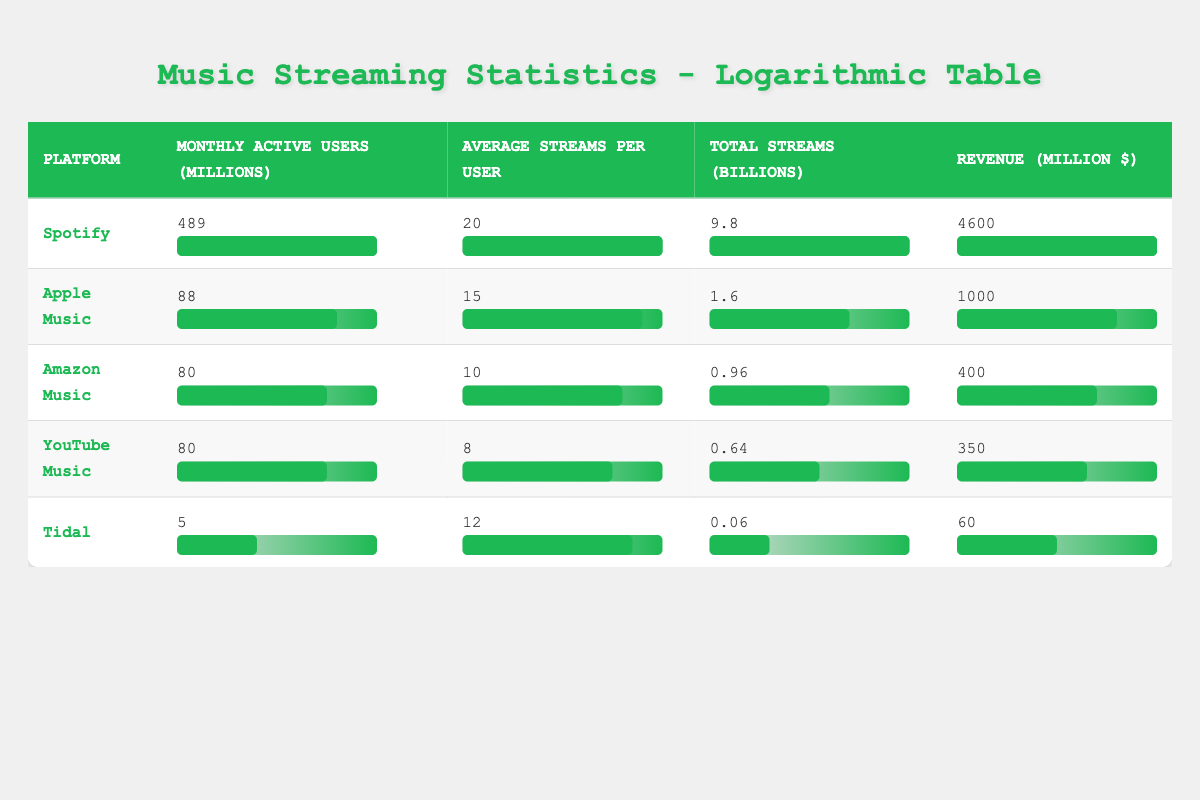What is the total revenue of Spotify? According to the table, the revenue for Spotify is listed directly under the revenue column, which shows 4600 million dollars.
Answer: 4600 million dollars Which platform has the highest number of monthly active users? The table lists monthly active users for each platform. Spotify has 489 million users, the highest compared to the other platforms.
Answer: Spotify What is the average number of streams per user on Apple Music? The table shows the average streams per user for Apple Music as 15. This value is found in the respective column for Apple Music.
Answer: 15 How many total streams did Tidal have in billions? Looking at the total streams column, Tidal is listed with 0.06 billion streams, which is directly taken from the table.
Answer: 0.06 billion What platform has a higher average streams per user, Amazon Music or YouTube Music? Amazon Music has an average of 10 streams per user while YouTube Music has 8. Comparing these values shows that Amazon Music has a higher average.
Answer: Amazon Music What is the combined total revenue of Apple Music and Amazon Music? For Apple Music, the revenue is 1000 million dollars and for Amazon Music, it's 400 million dollars. Adding these together gives 1000 + 400 = 1400 million dollars.
Answer: 1400 million dollars Is the total number of monthly active users higher on Spotify or on the combined total of Tidal and YouTube Music? Spotify has 489 million users, while Tidal has 5 million and YouTube Music has 80 million, so combined they have 5 + 80 = 85 million users. Since 489 is greater than 85, the answer is yes, Spotify has more.
Answer: Yes Which music streaming platform has the lowest total streams in billions? Revenue statistics in the table indicate that Tidal has the lowest total streams at 0.06 billion, as compared to other platforms like Spotify and Apple Music.
Answer: Tidal What is the average monthly active users for the platforms listed? To find the average, we sum the monthly active users: 489 (Spotify) + 88 (Apple Music) + 80 (Amazon Music) + 80 (YouTube Music) + 5 (Tidal) = 742 million. There are 5 platforms, so the average is 742 / 5 = 148.4 million users.
Answer: 148.4 million users 